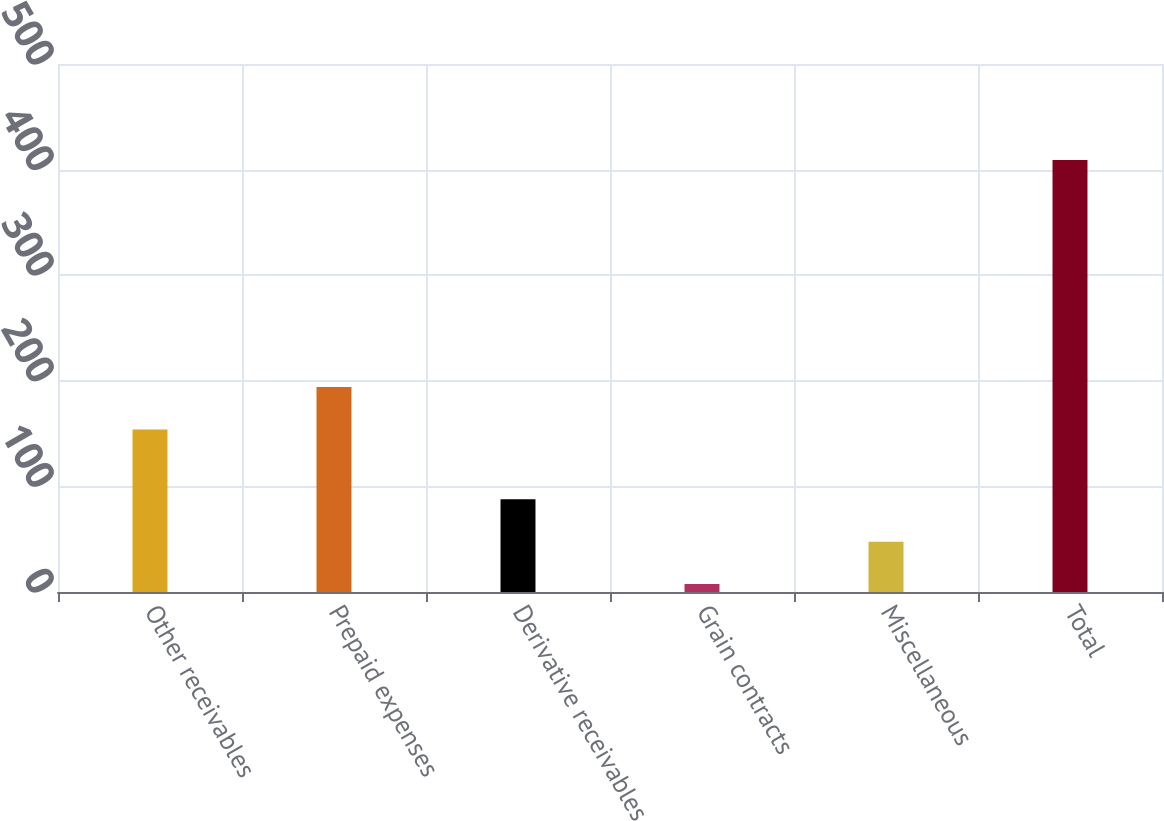<chart> <loc_0><loc_0><loc_500><loc_500><bar_chart><fcel>Other receivables<fcel>Prepaid expenses<fcel>Derivative receivables<fcel>Grain contracts<fcel>Miscellaneous<fcel>Total<nl><fcel>153.9<fcel>194.06<fcel>87.82<fcel>7.5<fcel>47.66<fcel>409.1<nl></chart> 